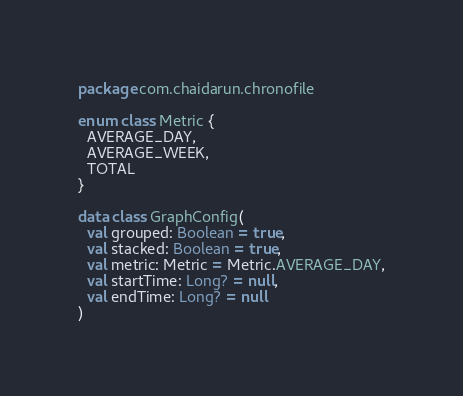<code> <loc_0><loc_0><loc_500><loc_500><_Kotlin_>package com.chaidarun.chronofile

enum class Metric {
  AVERAGE_DAY,
  AVERAGE_WEEK,
  TOTAL
}

data class GraphConfig(
  val grouped: Boolean = true,
  val stacked: Boolean = true,
  val metric: Metric = Metric.AVERAGE_DAY,
  val startTime: Long? = null,
  val endTime: Long? = null
)
</code> 